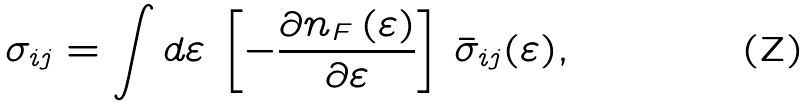<formula> <loc_0><loc_0><loc_500><loc_500>\sigma _ { i j } = \int d \varepsilon \, \left [ - \frac { \partial n _ { F } \left ( \varepsilon \right ) } { \partial \varepsilon } \right ] \, \bar { \sigma } _ { i j } ( \varepsilon ) ,</formula> 